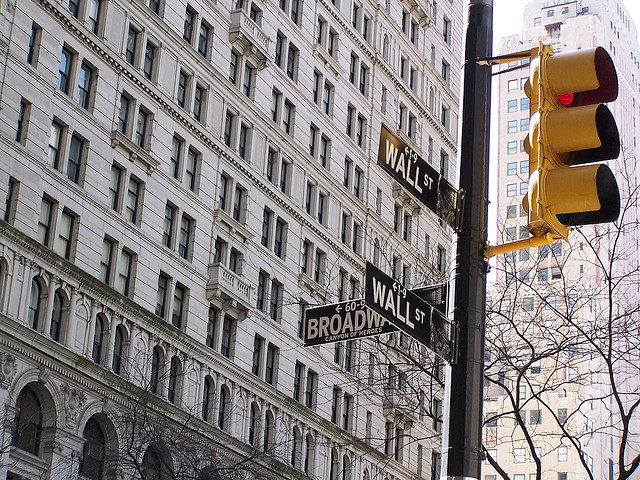Read all the text in this image. WALL ST WALL ST CANYON 60 60-9 